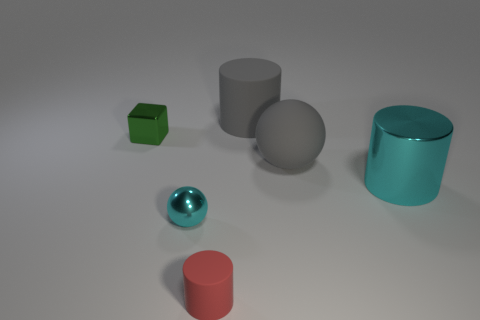What size is the metal thing that is both behind the tiny cyan object and to the right of the shiny cube?
Your response must be concise. Large. How many other things are there of the same shape as the small cyan metallic thing?
Give a very brief answer. 1. There is a tiny red cylinder; how many cyan metallic objects are behind it?
Your response must be concise. 2. Is the number of matte objects that are behind the small matte cylinder less than the number of large shiny things behind the large rubber ball?
Your answer should be very brief. No. There is a tiny thing that is right of the ball left of the matte cylinder that is in front of the small ball; what shape is it?
Ensure brevity in your answer.  Cylinder. The thing that is behind the metallic cylinder and on the left side of the gray cylinder has what shape?
Provide a succinct answer. Cube. Are there any tiny objects made of the same material as the gray cylinder?
Keep it short and to the point. Yes. There is a thing that is the same color as the large metal cylinder; what size is it?
Your answer should be very brief. Small. There is a big matte ball that is on the left side of the large shiny cylinder; what color is it?
Provide a short and direct response. Gray. Do the big cyan object and the rubber thing in front of the cyan metallic ball have the same shape?
Your answer should be very brief. Yes. 